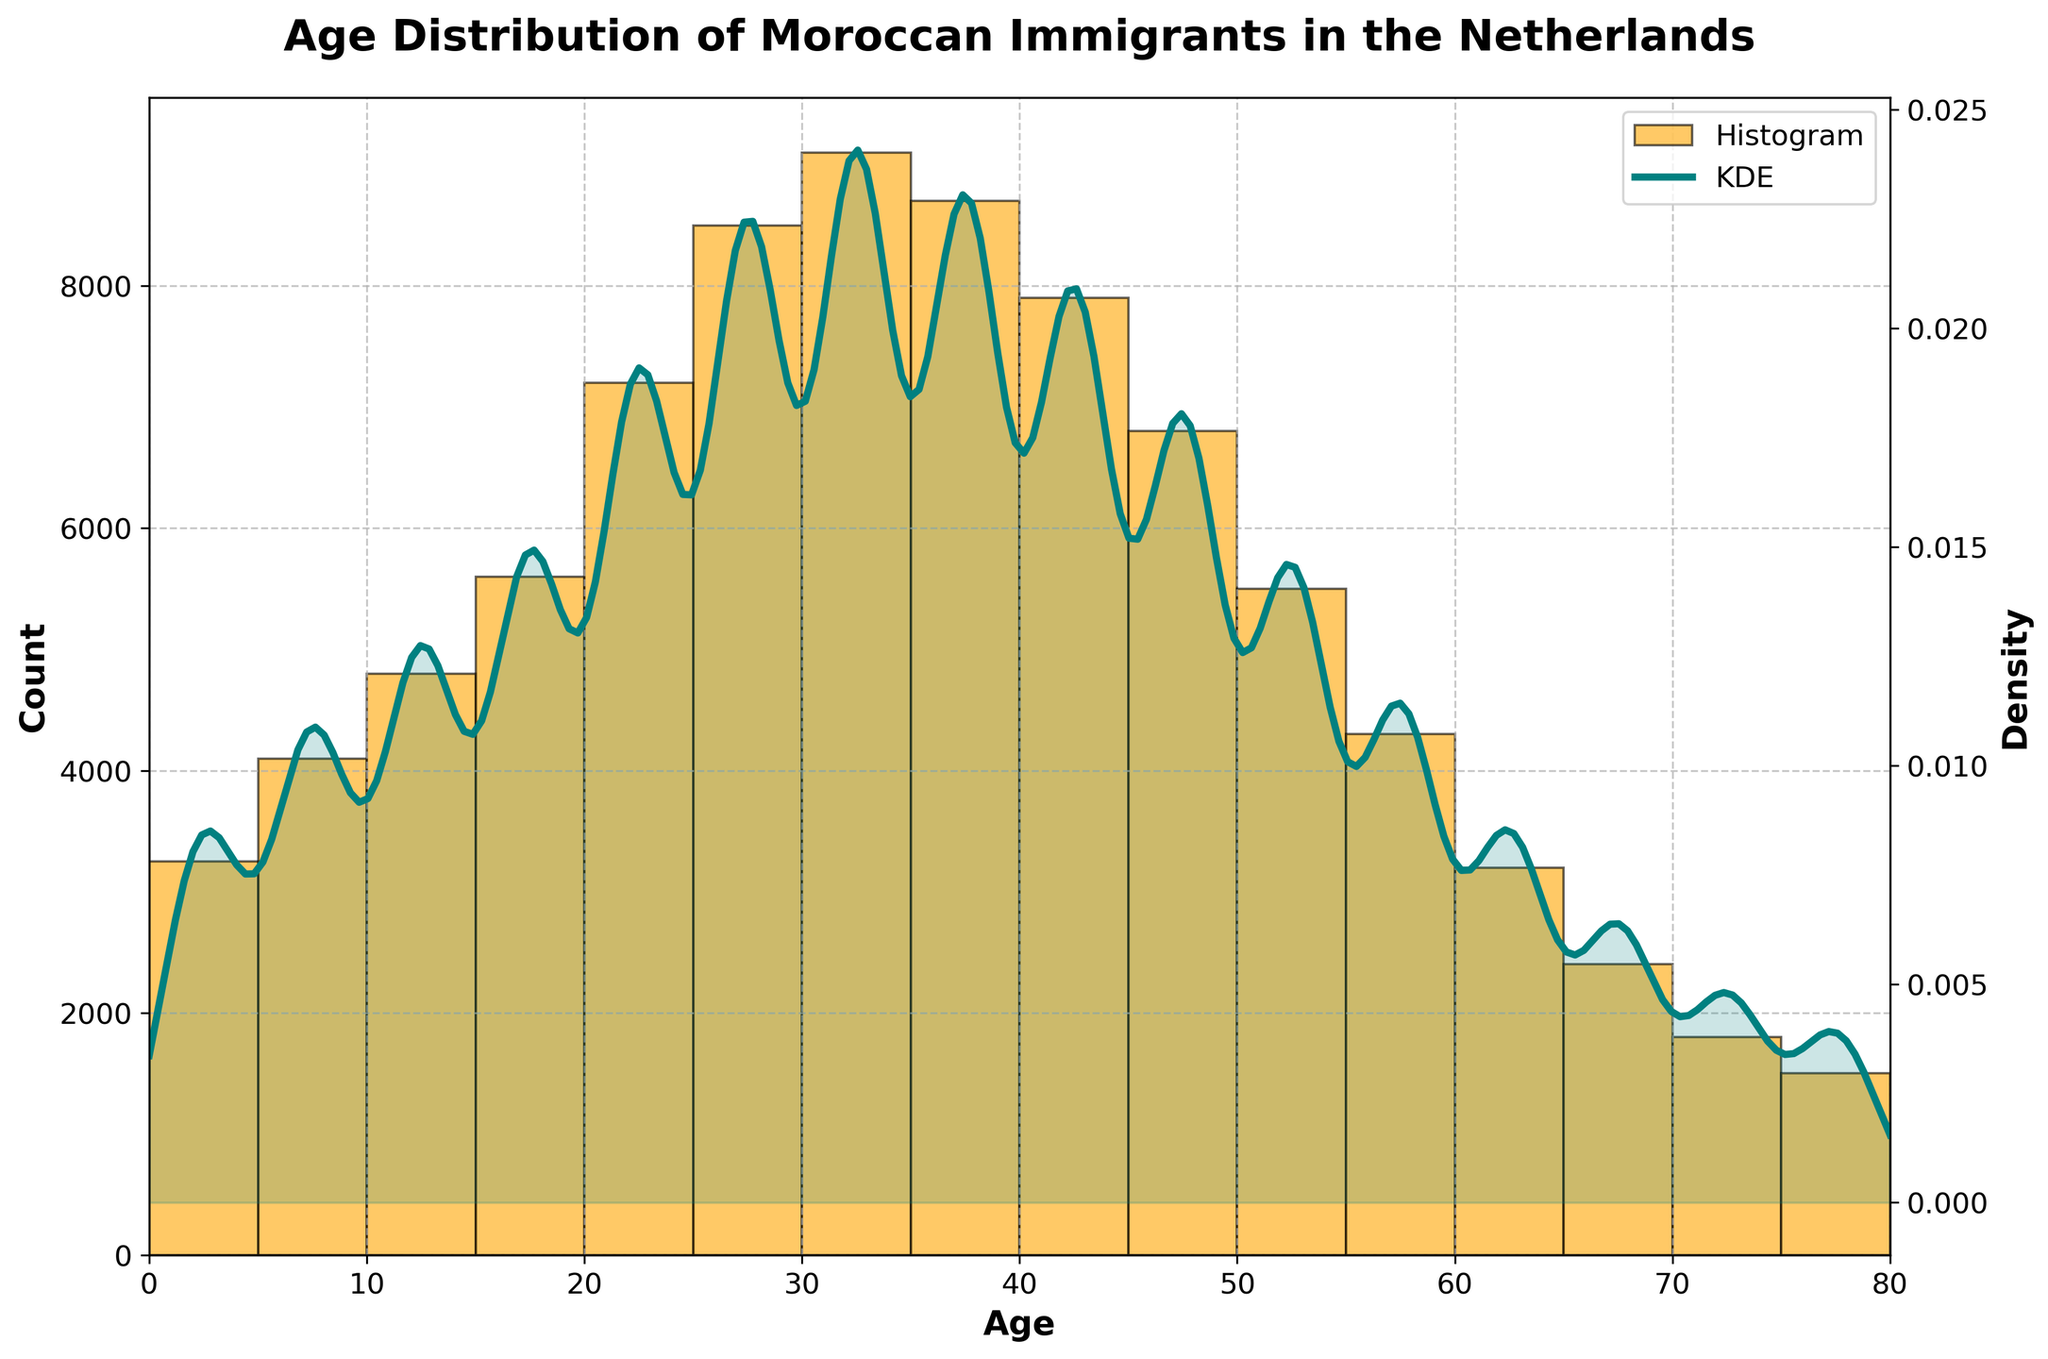What's the title of the plot? The title is usually displayed at the top of the plot and provides a summary of what the plot illustrates. In this case, it says "Age Distribution of Moroccan Immigrants in the Netherlands".
Answer: Age Distribution of Moroccan Immigrants in the Netherlands What age range has the highest count of Moroccan immigrants in the Netherlands? By examining the height of the bars in the histogram, the tallest bar indicates the age range with the highest count. The highest bar appears at the age range of 30-34.
Answer: 30-34 Which age range has a count of 4800? To find this, look for the bar that has a corresponding height value of 4800 on the y-axis. This bar is located at the age range 10-14.
Answer: 10-14 What is the general trend in the count of Moroccan immigrants as age increases? Observing the histogram, it is noticeable that the counts generally increase from younger age ranges to age ranges around 30-34, after which the counts generally decrease as age increases further.
Answer: Increase, then decrease Which age range has a higher immigrant count, 25-29 or 45-49? Comparing the height of the bars for ages 25-29 and 45-49, the bar for 25-29 is higher than that for 45-49.
Answer: 25-29 What is the median age range in the dataset? To find the median age range, sort the age ranges by count and find the middle point. Since the data is already in order, and considering 16 data points, the median is the average of the 8th and 9th points. The age ranges for these positions are 35-39 and 40-44. Therefore, the median age range is between these two.
Answer: 35-39 and 40-44 Describe the shape of the KDE curve and its relation to the histogram. The KDE curve is a smooth line representing the estimated probability density of the data. It peaks around the age range with the highest counts (30-34) and spans across the range of the histogram bars, depicting a smooth approximation of the distribution.
Answer: The KDE curve peaks around 30-34 and smooths out the histogram distribution How does the count of 15-19 year-olds compare to the count of 50-54 year-olds? Look at the height of the bars for the age ranges 15-19 and 50-54. The bar for 15-19 is significantly taller than the bar for 50-54, indicating a higher count of 15-19 year-olds.
Answer: Higher for 15-19 year-olds Which age range has a density value of approximately 0.05 on the KDE curve? To find this, observe the KDE curve closely and see where it reaches about 0.05. This appears to be around the age range 20-24.
Answer: 20-24 